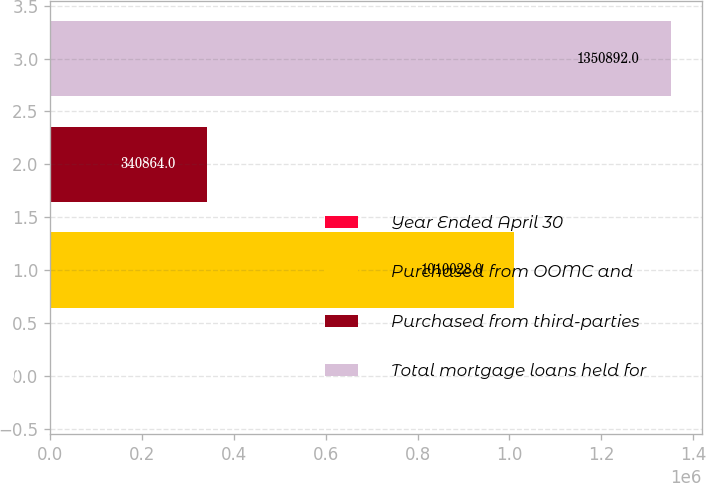Convert chart. <chart><loc_0><loc_0><loc_500><loc_500><bar_chart><fcel>Year Ended April 30<fcel>Purchased from OOMC and<fcel>Purchased from third-parties<fcel>Total mortgage loans held for<nl><fcel>2007<fcel>1.01003e+06<fcel>340864<fcel>1.35089e+06<nl></chart> 